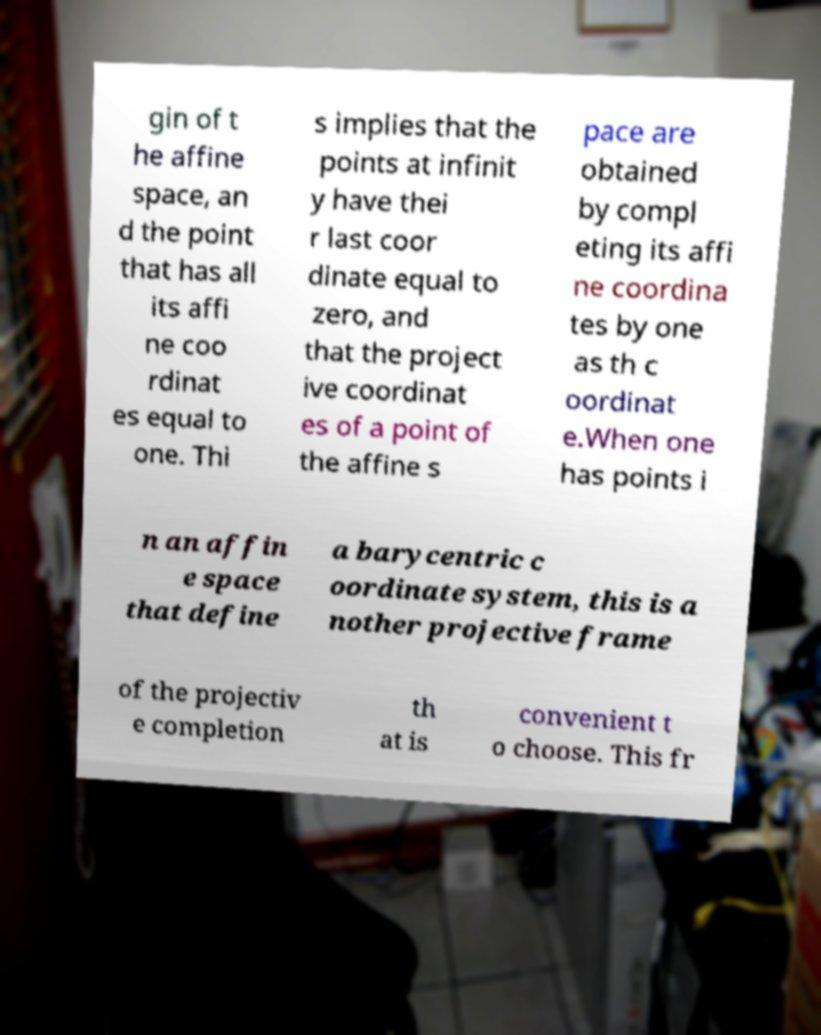Please read and relay the text visible in this image. What does it say? gin of t he affine space, an d the point that has all its affi ne coo rdinat es equal to one. Thi s implies that the points at infinit y have thei r last coor dinate equal to zero, and that the project ive coordinat es of a point of the affine s pace are obtained by compl eting its affi ne coordina tes by one as th c oordinat e.When one has points i n an affin e space that define a barycentric c oordinate system, this is a nother projective frame of the projectiv e completion th at is convenient t o choose. This fr 